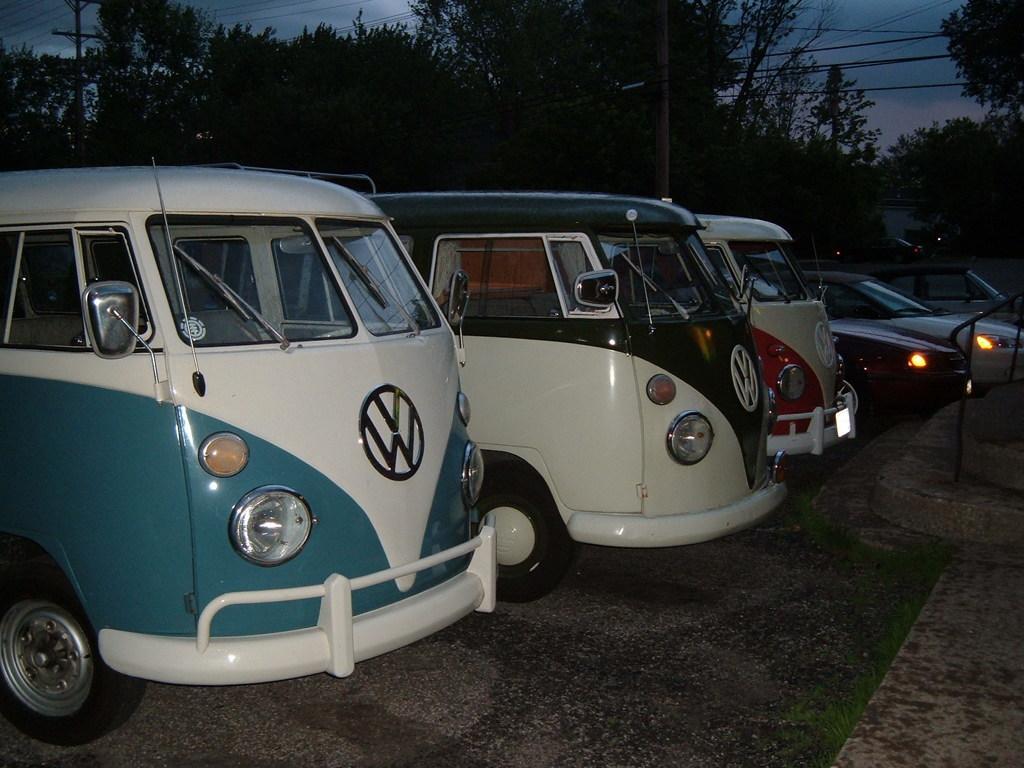Please provide a concise description of this image. In this image there are vehicles on a road, in the background there are trees, poles and wires. 